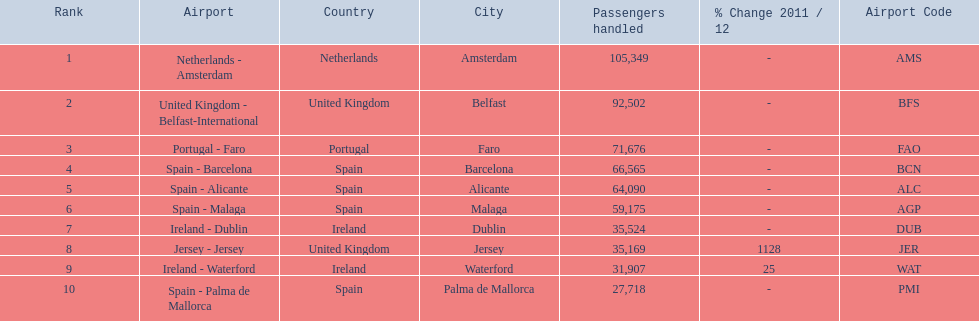What is the best rank? 1. What is the airport? Netherlands - Amsterdam. 